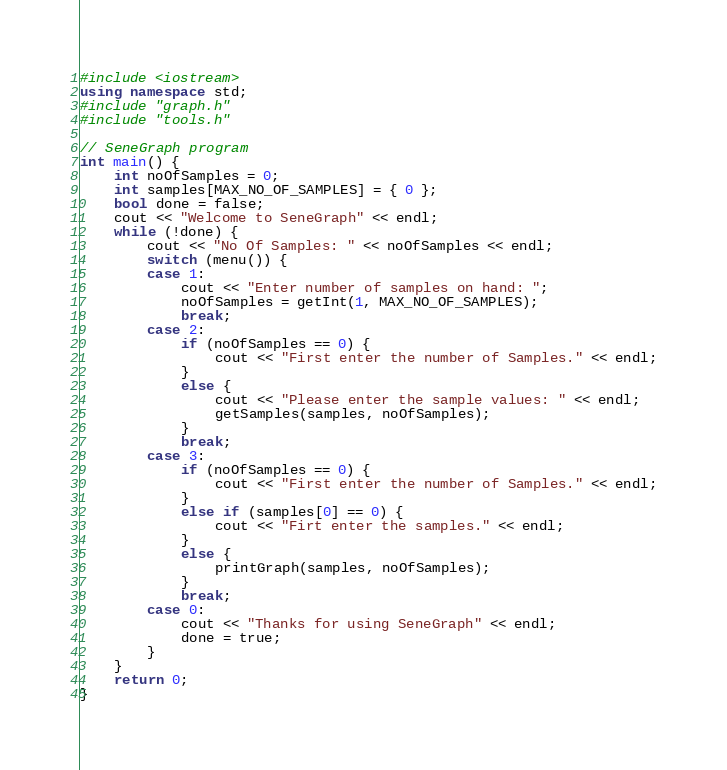<code> <loc_0><loc_0><loc_500><loc_500><_C++_>#include <iostream>
using namespace std;
#include "graph.h"
#include "tools.h"

// SeneGraph program
int main() {
	int noOfSamples = 0;
	int samples[MAX_NO_OF_SAMPLES] = { 0 };
	bool done = false;
	cout << "Welcome to SeneGraph" << endl;
	while (!done) {
		cout << "No Of Samples: " << noOfSamples << endl;
		switch (menu()) {
		case 1:
			cout << "Enter number of samples on hand: ";
			noOfSamples = getInt(1, MAX_NO_OF_SAMPLES);
			break;
		case 2:
			if (noOfSamples == 0) {
				cout << "First enter the number of Samples." << endl;
			}
			else {
				cout << "Please enter the sample values: " << endl;
				getSamples(samples, noOfSamples);
			}
			break;
		case 3:
			if (noOfSamples == 0) {
				cout << "First enter the number of Samples." << endl;
			}
			else if (samples[0] == 0) {
				cout << "Firt enter the samples." << endl;
			}
			else {
				printGraph(samples, noOfSamples);
			}
			break;
		case 0:
			cout << "Thanks for using SeneGraph" << endl;
			done = true;
		}
	}
	return 0;
}

</code> 